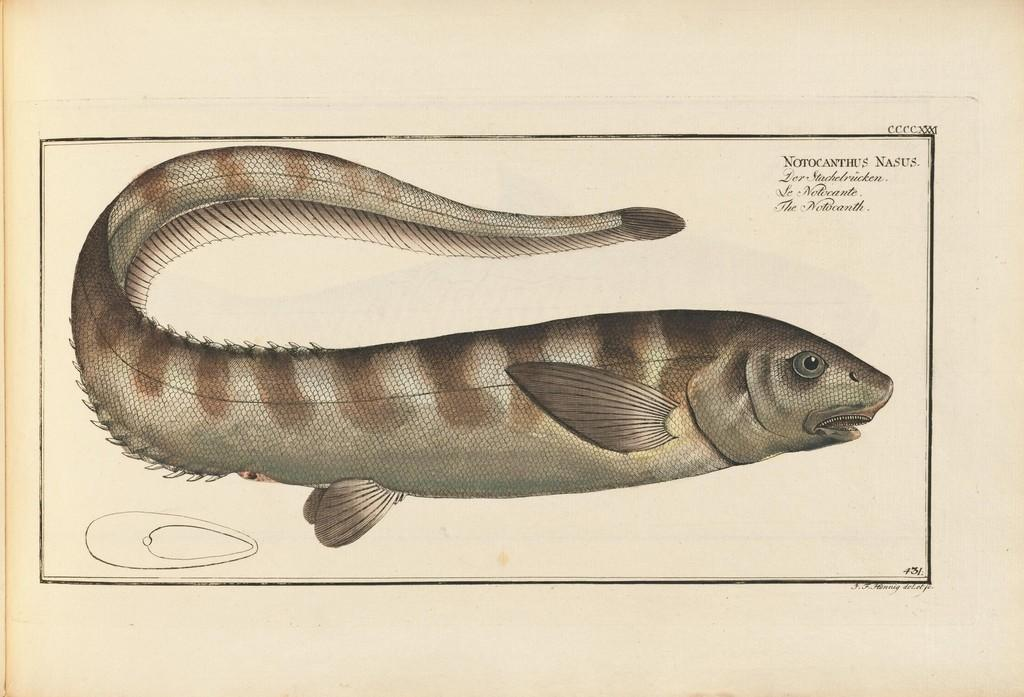What is depicted on the paper in the image? There is a picture of a fish on a paper in the image. What else can be seen on the paper besides the fish? There is text on the paper in the image. Where is the nut placed in the image? There is no nut present in the image. What type of seat can be seen in the image? There is no seat present in the image. 